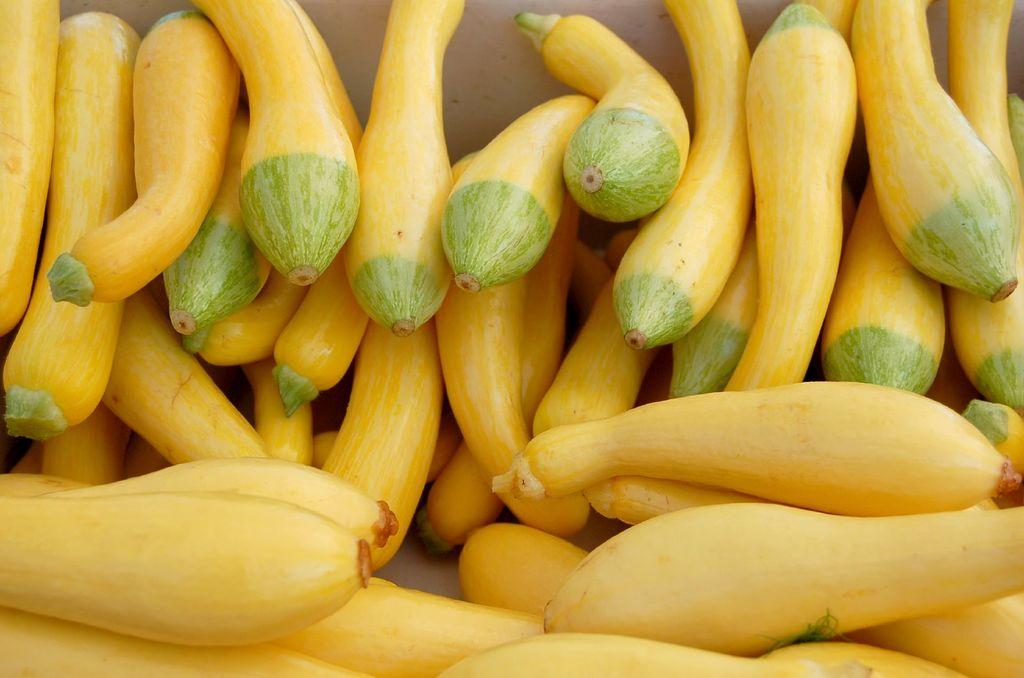What type of food can be seen in the image? There are vegetables in the image. What type of glue is being used to attach the wing to the seat in the image? There is no glue, wing, or seat present in the image; it only features vegetables. 